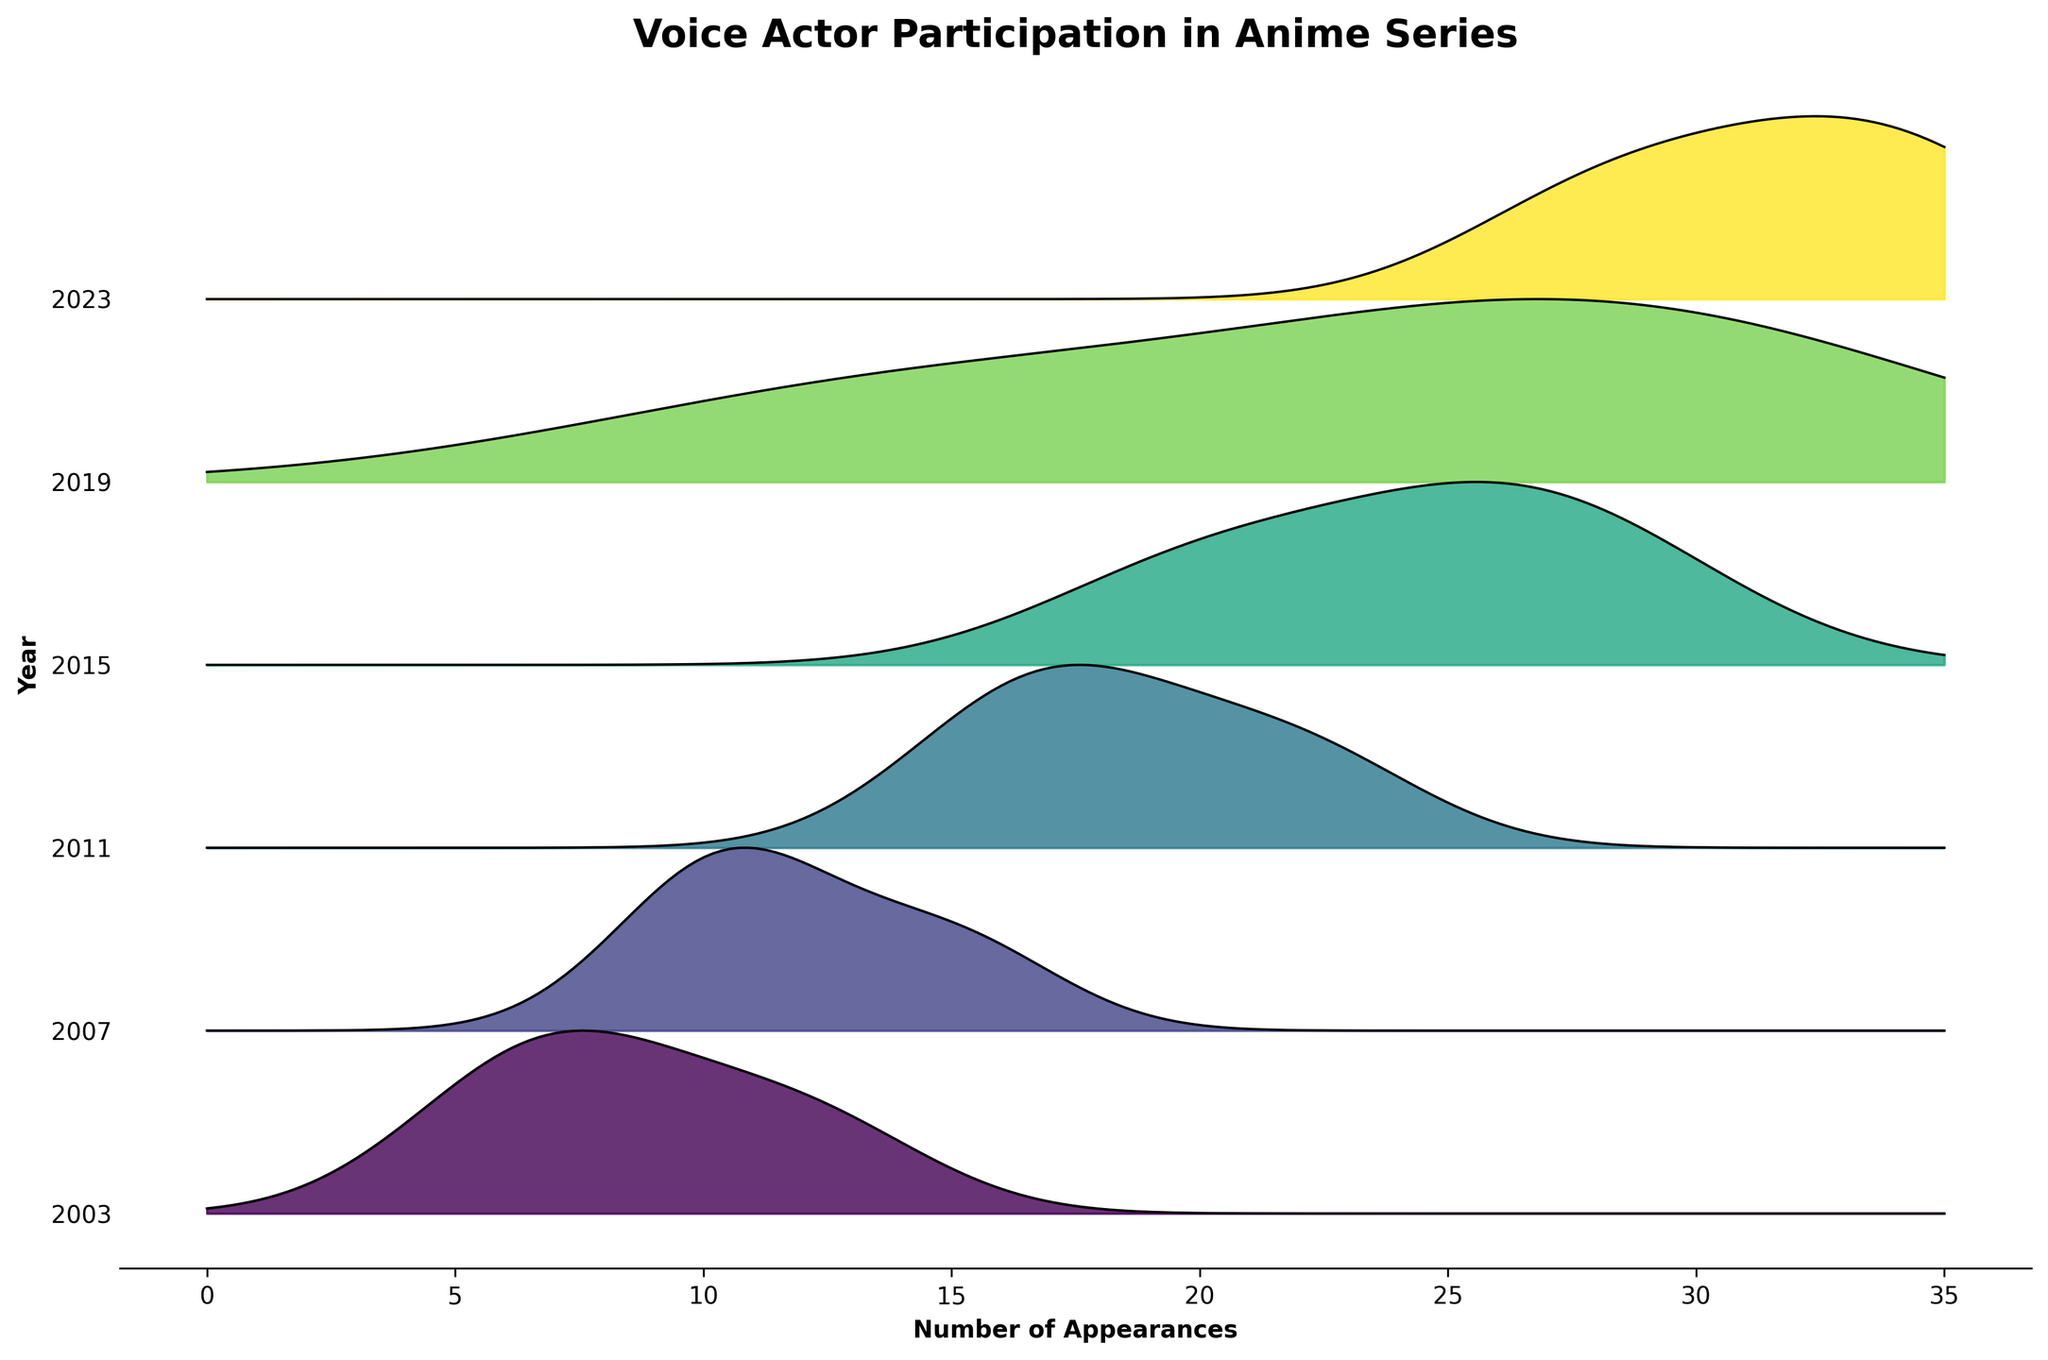What is the title of the plot? The title is usually located at the top of the plot. It is often in a larger, bold font to make it stand out. For this plot, the title is "Voice Actor Participation in Anime Series."
Answer: Voice Actor Participation in Anime Series Which year has the highest peak for appearances? Locate the ridge with the highest peak on the y-axis, which in ridgeline plots usually represents the density of data points clustered around certain values. For 2023, you can observe that the distributions are the highest.
Answer: 2023 How many unique years are depicted in the plot? Count the unique labels on the y-axis. These labels represent the different years included in the dataset. There are labels for 2003, 2007, 2011, 2015, 2019, and 2023.
Answer: 6 Which voice actor had the highest number of appearances in a single year, and what was the count? Look at the ridgeline that has the highest peak and check the corresponding year. For each year, identify the peak appearance from the dataset and note the actor. In 2023, Akari Kitō had the highest appearances at 35.
Answer: Akari Kitō with 35 appearances Is the number of voice actor appearances generally increasing or decreasing over the years? Observe the overall density and height of the ridgelines. Compare the ridgelines from earlier years (e.g., 2003) to the later years (e.g., 2023). From the plot, it is evident that the density and peaks of later years are higher, indicating an increasing trend.
Answer: Increasing Who had more appearances in 2011, Yuki Kaji or Kana Hanazawa? Refer to the figure for data points in the 2011 ridgeline. Check the peaks for each actor in the 2011 dataset. Yuki Kaji had 18 appearances and Kana Hanazawa had 22 appearances.
Answer: Kana Hanazawa What are the maximum and minimum appearances recorded in the plot? Identify the highest and lowest points across all ridgelines. From the data, the maximum is 35 appearances by Akari Kitō in 2023, and the minimum is 6 appearances by Kōichi Yamadera in 2003.
Answer: 35 and 6 Compare the distribution between 2003 and 2023. Which year has a more varied appearance count? Inspect the width and spread of the ridgelines for both years. A wider and more spread-out ridgeline indicates more variance in data. The 2023 ridgeline shows a higher variance compared to the 2003 ridgeline, which is more compact.
Answer: 2023 Which year recorded the highest density of an actor having between 25-30 appearances? Look for the ridgeline that peaks around the 25-30 appearances mark. For 2019, Natsuki Hanae had 30 appearances, which is within the range.
Answer: 2019 How did Maaya Sakamoto's appearance frequency change from 2003 to 2007? Compare the appearance counts for Maaya Sakamoto in both years from the dataset. In 2003, Maaya Sakamoto had 8 appearances, while in 2007, she had 11 appearances. The frequency increased.
Answer: Increased 